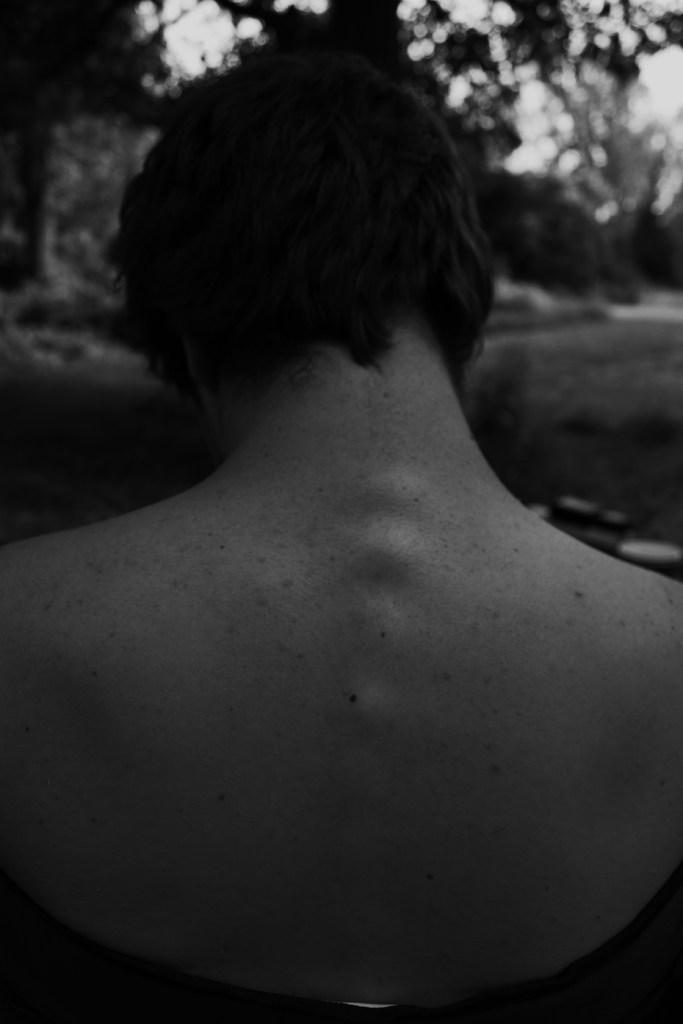What is the color scheme of the image? The image is black and white. Can you describe the main subject of the image? There is a person in the image. How many lizards can be seen in the image? There are no lizards present in the image. What is the rate of the person's movement in the image? The image is still, so there is no rate of movement for the person. 